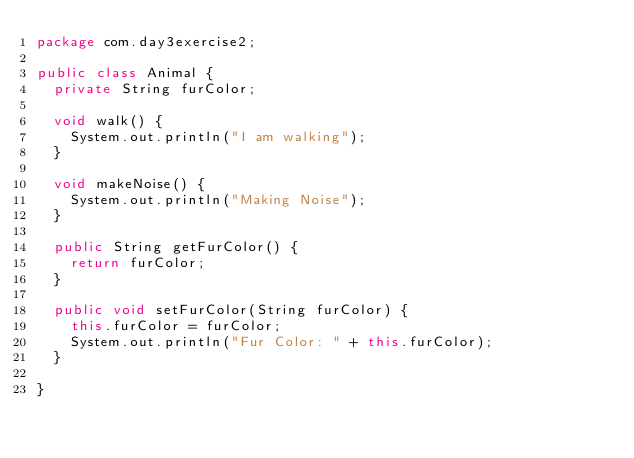<code> <loc_0><loc_0><loc_500><loc_500><_Java_>package com.day3exercise2;

public class Animal {
	private String furColor;

	void walk() {
		System.out.println("I am walking");
	}

	void makeNoise() {
		System.out.println("Making Noise");
	}

	public String getFurColor() {
		return furColor;
	}

	public void setFurColor(String furColor) {
		this.furColor = furColor;
		System.out.println("Fur Color: " + this.furColor);
	}

}
</code> 